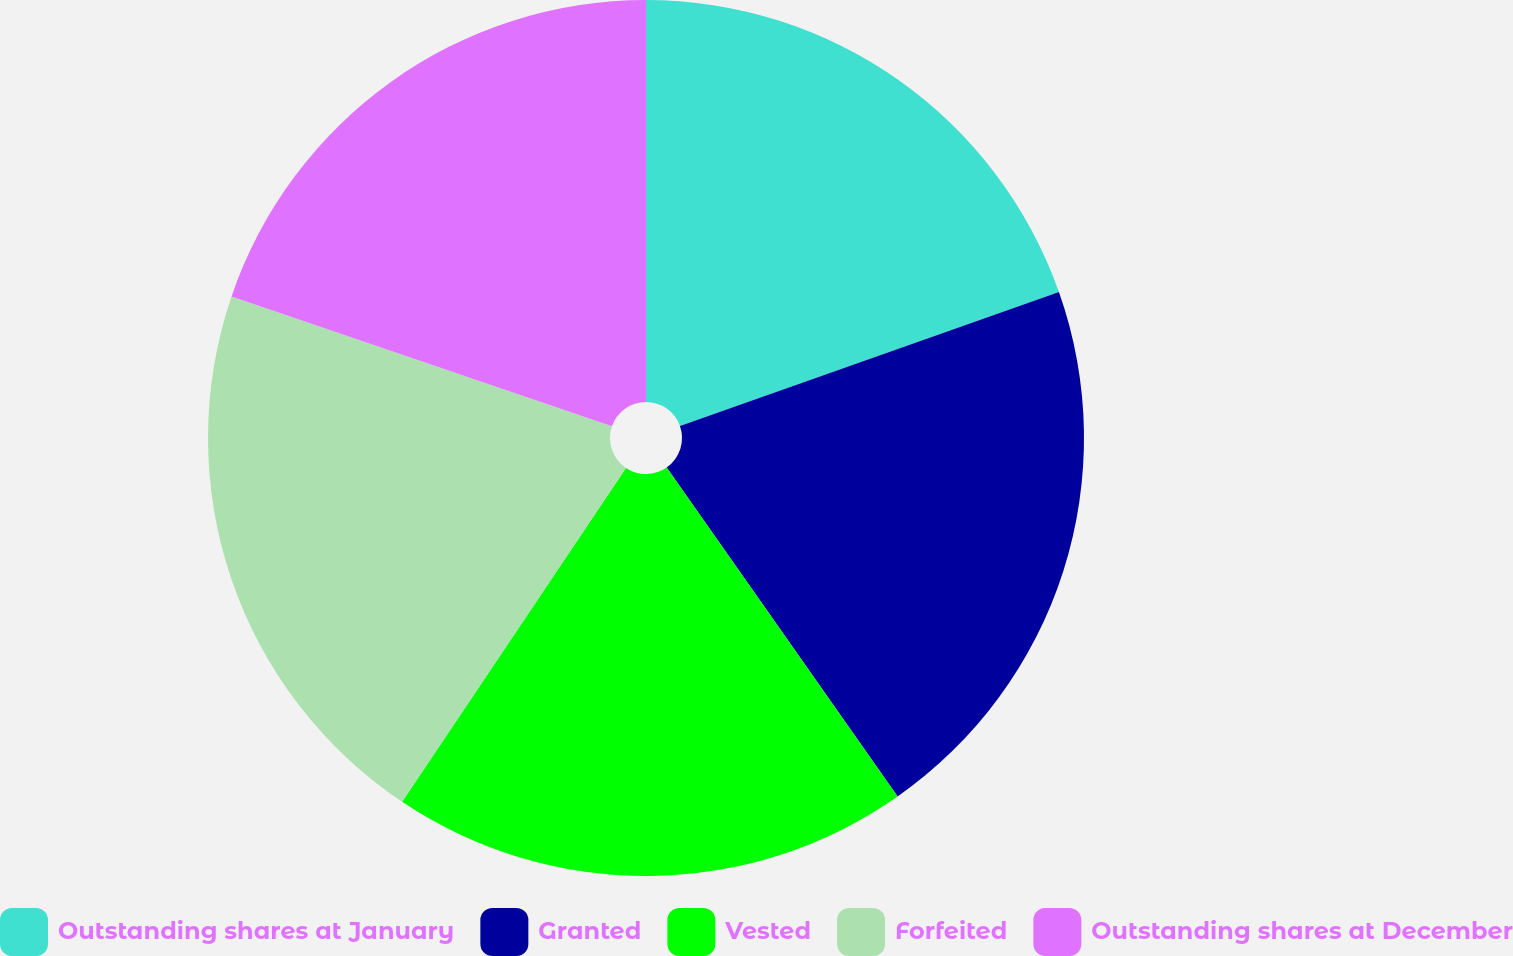Convert chart to OTSL. <chart><loc_0><loc_0><loc_500><loc_500><pie_chart><fcel>Outstanding shares at January<fcel>Granted<fcel>Vested<fcel>Forfeited<fcel>Outstanding shares at December<nl><fcel>19.59%<fcel>20.67%<fcel>19.14%<fcel>20.84%<fcel>19.76%<nl></chart> 